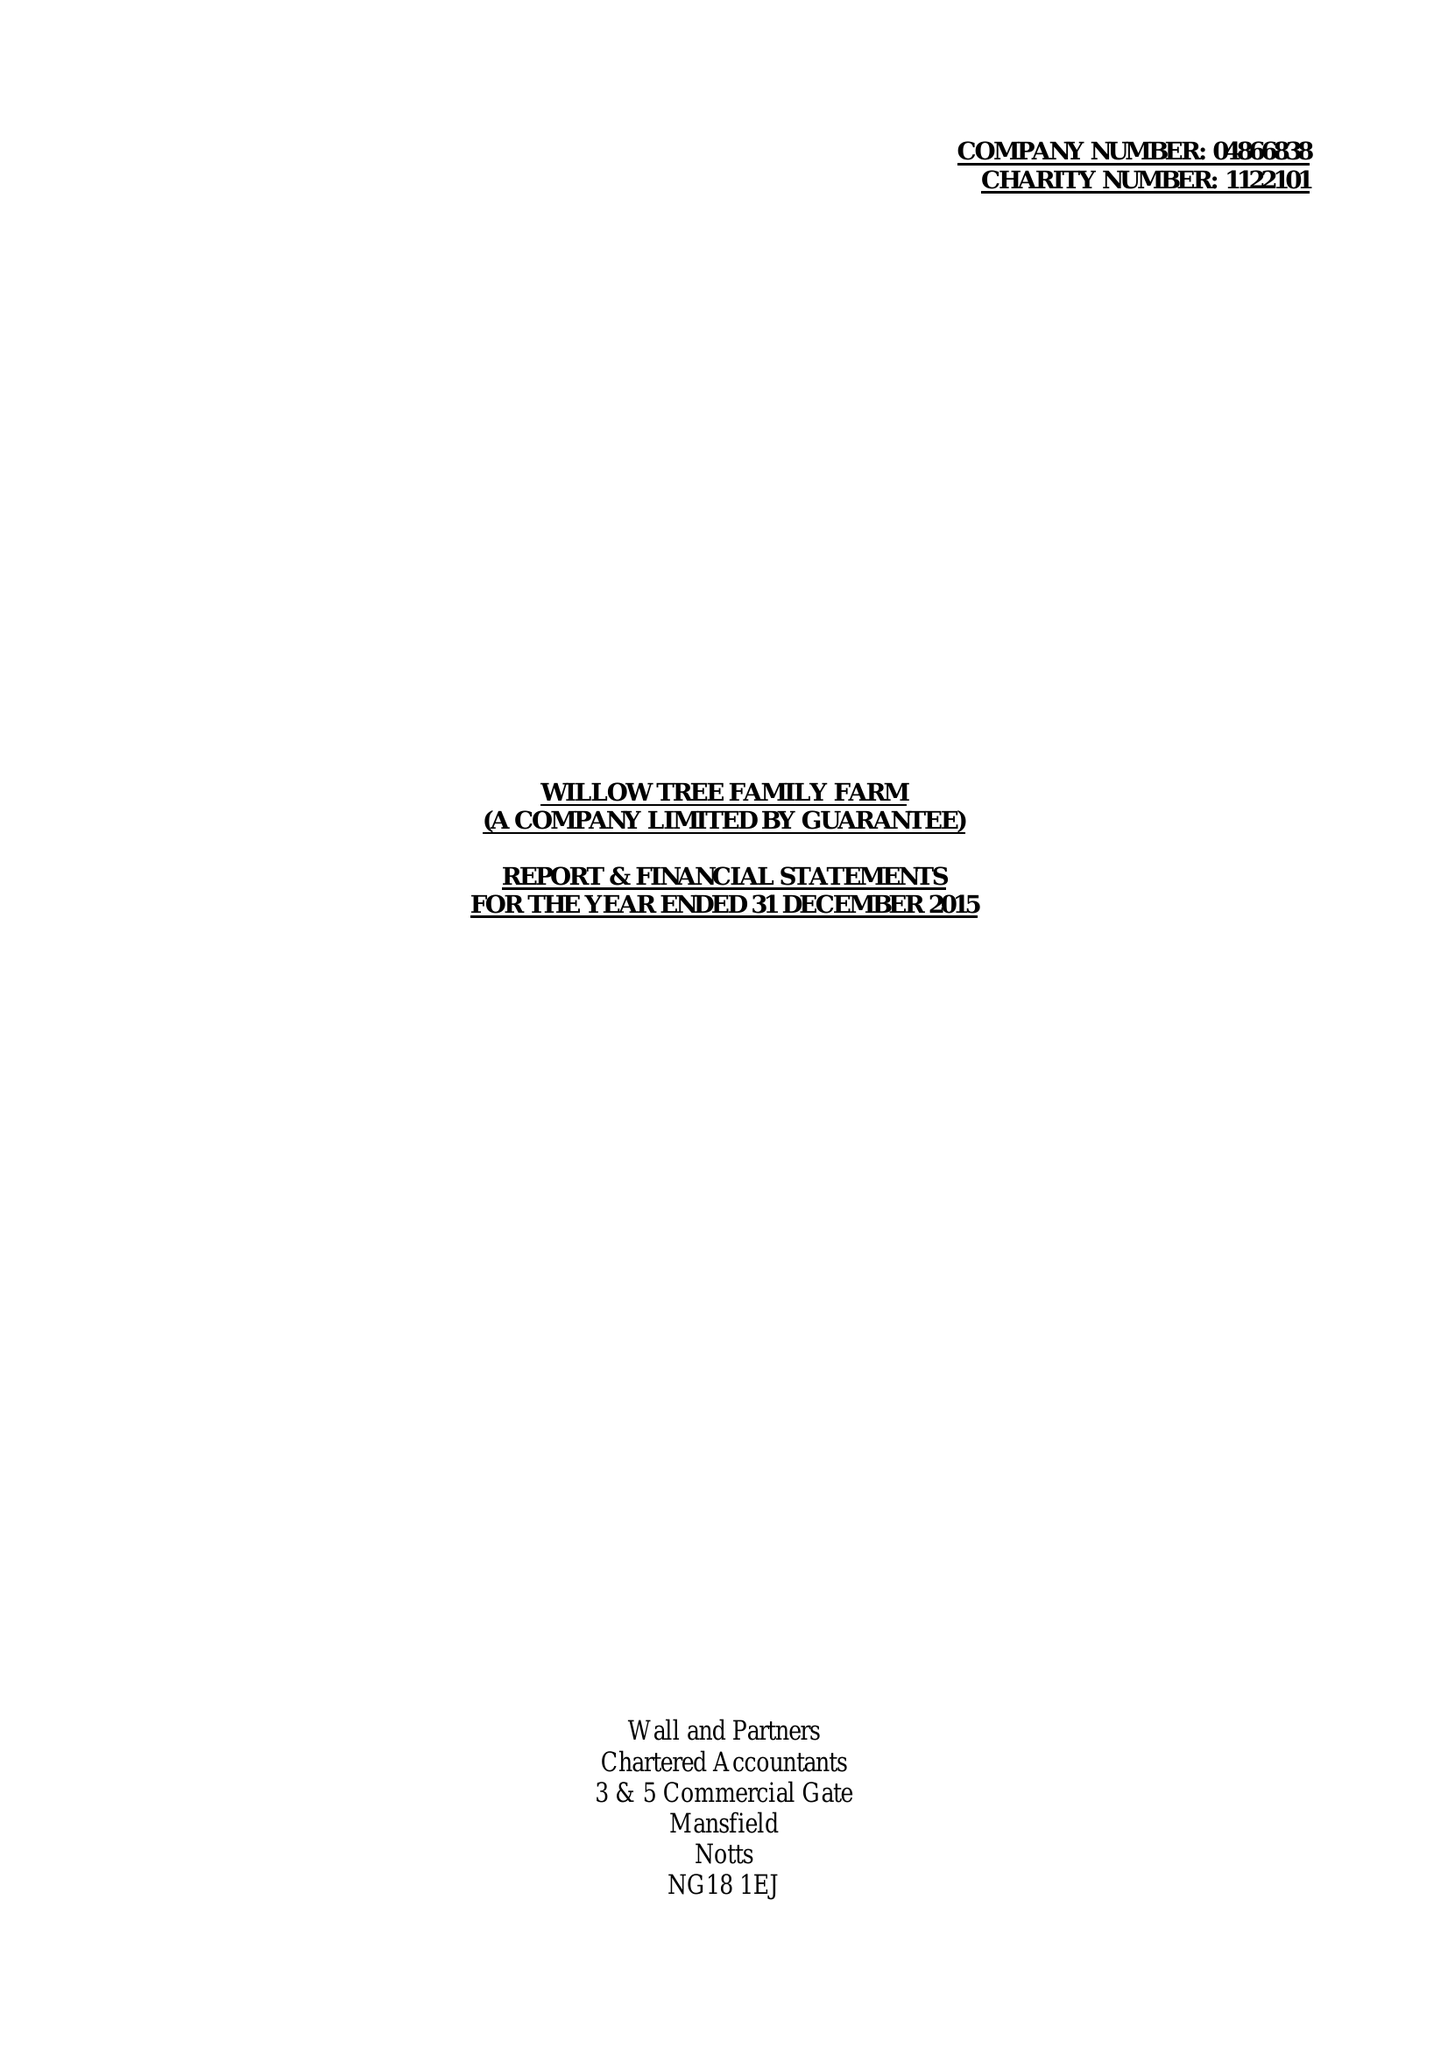What is the value for the address__street_line?
Answer the question using a single word or phrase. LANGWITH ROAD 